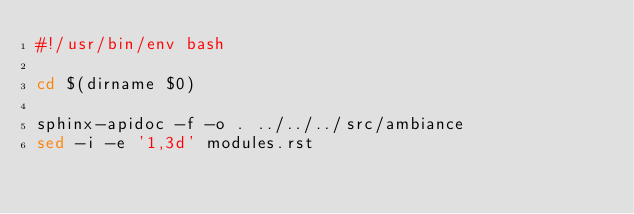Convert code to text. <code><loc_0><loc_0><loc_500><loc_500><_Bash_>#!/usr/bin/env bash

cd $(dirname $0)

sphinx-apidoc -f -o . ../../../src/ambiance
sed -i -e '1,3d' modules.rst
</code> 